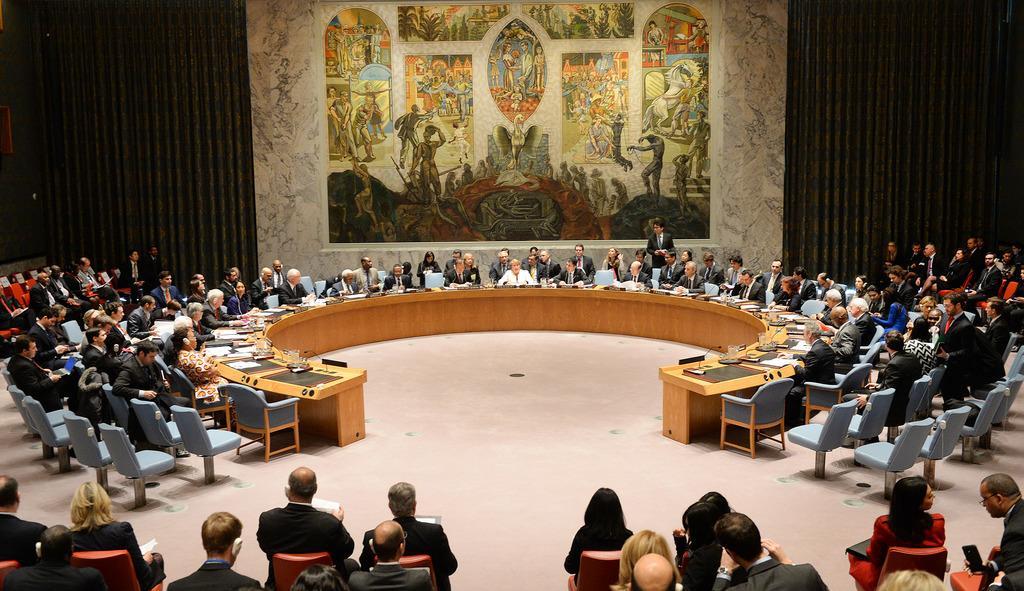Describe this image in one or two sentences. This picture is inside view of a room. Here we can see group of people are sitting in a conference room. In this we can see table, chairs, books, mics, paper, wall, floor are present. 